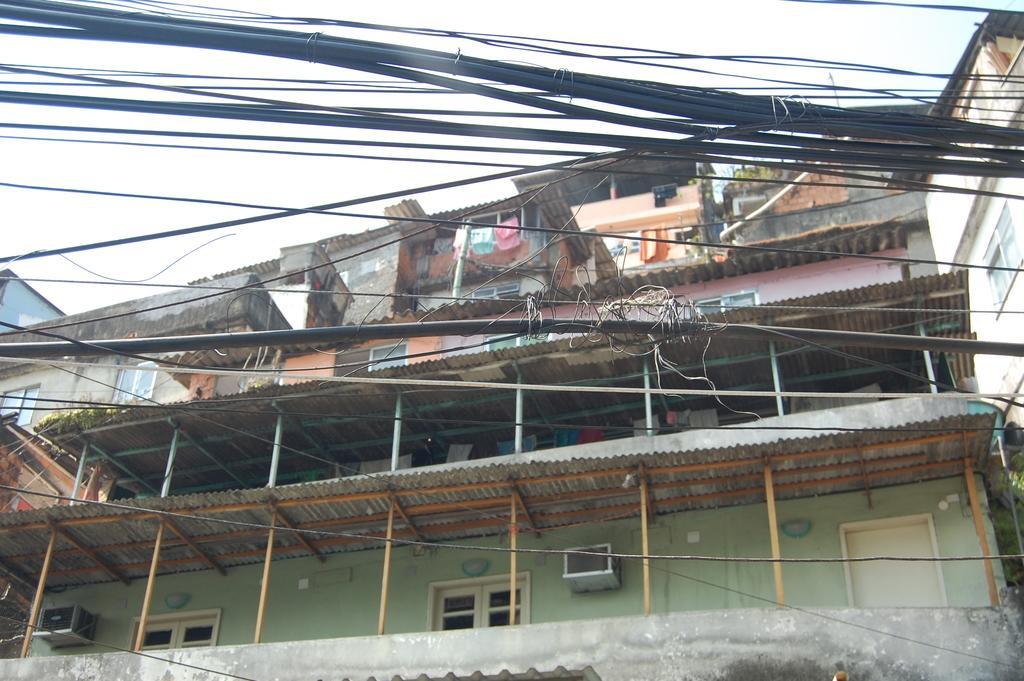Please provide a concise description of this image. In this image there is a building having few clothes and plants. Front side of image there are few wires. Top of image there is sky. 